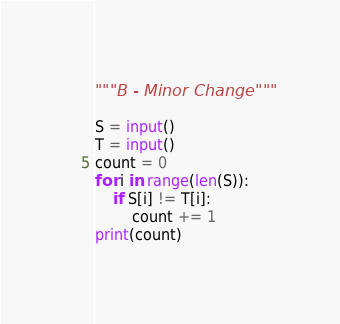<code> <loc_0><loc_0><loc_500><loc_500><_Python_>"""B - Minor Change"""

S = input()
T = input()
count = 0
for i in range(len(S)):
    if S[i] != T[i]:
        count += 1
print(count)
</code> 